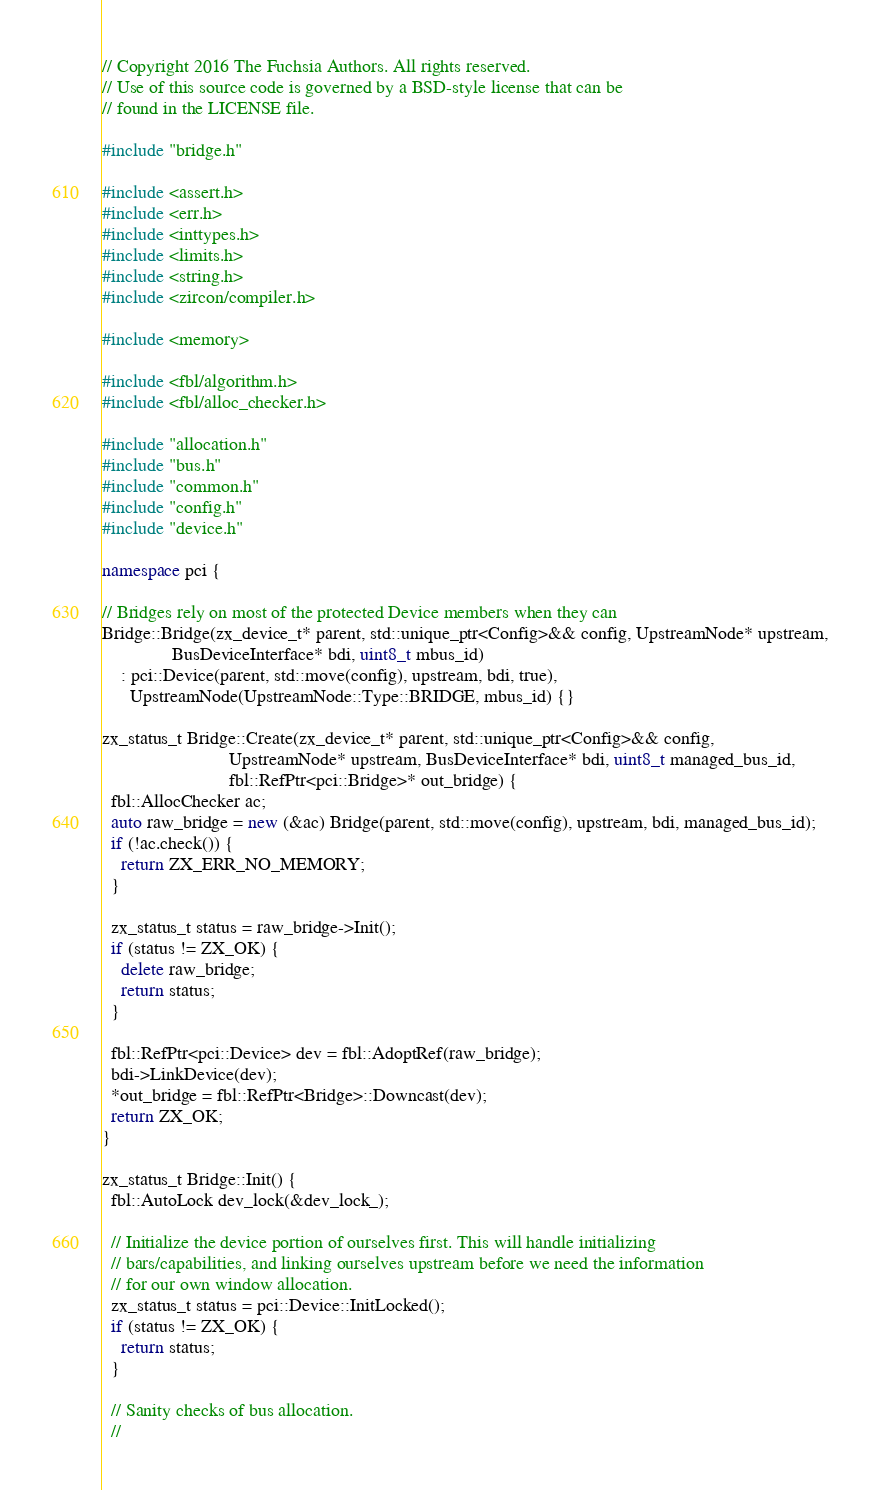<code> <loc_0><loc_0><loc_500><loc_500><_C++_>// Copyright 2016 The Fuchsia Authors. All rights reserved.
// Use of this source code is governed by a BSD-style license that can be
// found in the LICENSE file.

#include "bridge.h"

#include <assert.h>
#include <err.h>
#include <inttypes.h>
#include <limits.h>
#include <string.h>
#include <zircon/compiler.h>

#include <memory>

#include <fbl/algorithm.h>
#include <fbl/alloc_checker.h>

#include "allocation.h"
#include "bus.h"
#include "common.h"
#include "config.h"
#include "device.h"

namespace pci {

// Bridges rely on most of the protected Device members when they can
Bridge::Bridge(zx_device_t* parent, std::unique_ptr<Config>&& config, UpstreamNode* upstream,
               BusDeviceInterface* bdi, uint8_t mbus_id)
    : pci::Device(parent, std::move(config), upstream, bdi, true),
      UpstreamNode(UpstreamNode::Type::BRIDGE, mbus_id) {}

zx_status_t Bridge::Create(zx_device_t* parent, std::unique_ptr<Config>&& config,
                           UpstreamNode* upstream, BusDeviceInterface* bdi, uint8_t managed_bus_id,
                           fbl::RefPtr<pci::Bridge>* out_bridge) {
  fbl::AllocChecker ac;
  auto raw_bridge = new (&ac) Bridge(parent, std::move(config), upstream, bdi, managed_bus_id);
  if (!ac.check()) {
    return ZX_ERR_NO_MEMORY;
  }

  zx_status_t status = raw_bridge->Init();
  if (status != ZX_OK) {
    delete raw_bridge;
    return status;
  }

  fbl::RefPtr<pci::Device> dev = fbl::AdoptRef(raw_bridge);
  bdi->LinkDevice(dev);
  *out_bridge = fbl::RefPtr<Bridge>::Downcast(dev);
  return ZX_OK;
}

zx_status_t Bridge::Init() {
  fbl::AutoLock dev_lock(&dev_lock_);

  // Initialize the device portion of ourselves first. This will handle initializing
  // bars/capabilities, and linking ourselves upstream before we need the information
  // for our own window allocation.
  zx_status_t status = pci::Device::InitLocked();
  if (status != ZX_OK) {
    return status;
  }

  // Sanity checks of bus allocation.
  //</code> 